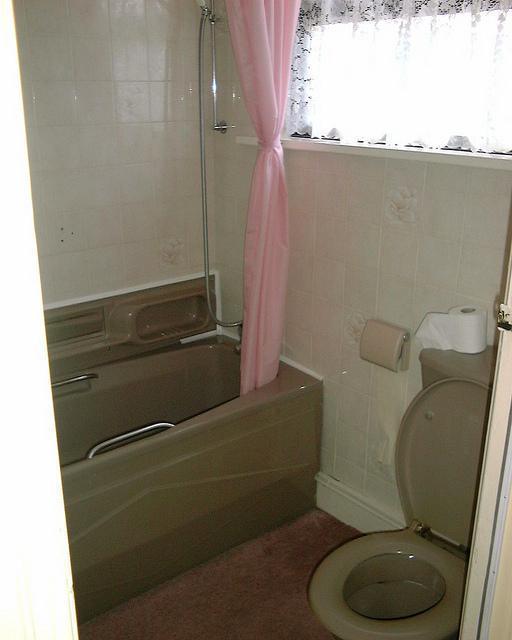How many rolls of toilet paper are there?
Give a very brief answer. 2. 